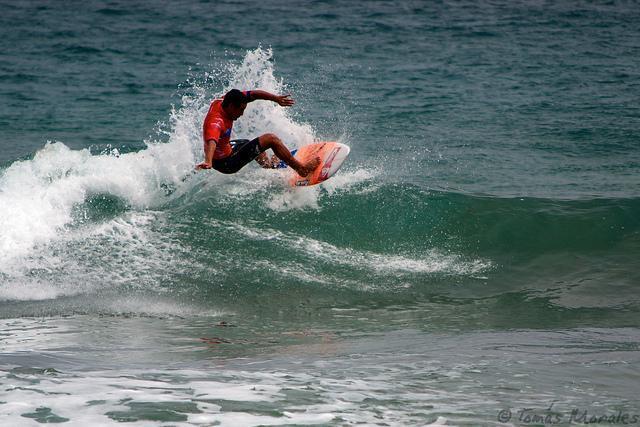How many people can you see?
Give a very brief answer. 1. How many zebras are there?
Give a very brief answer. 0. 